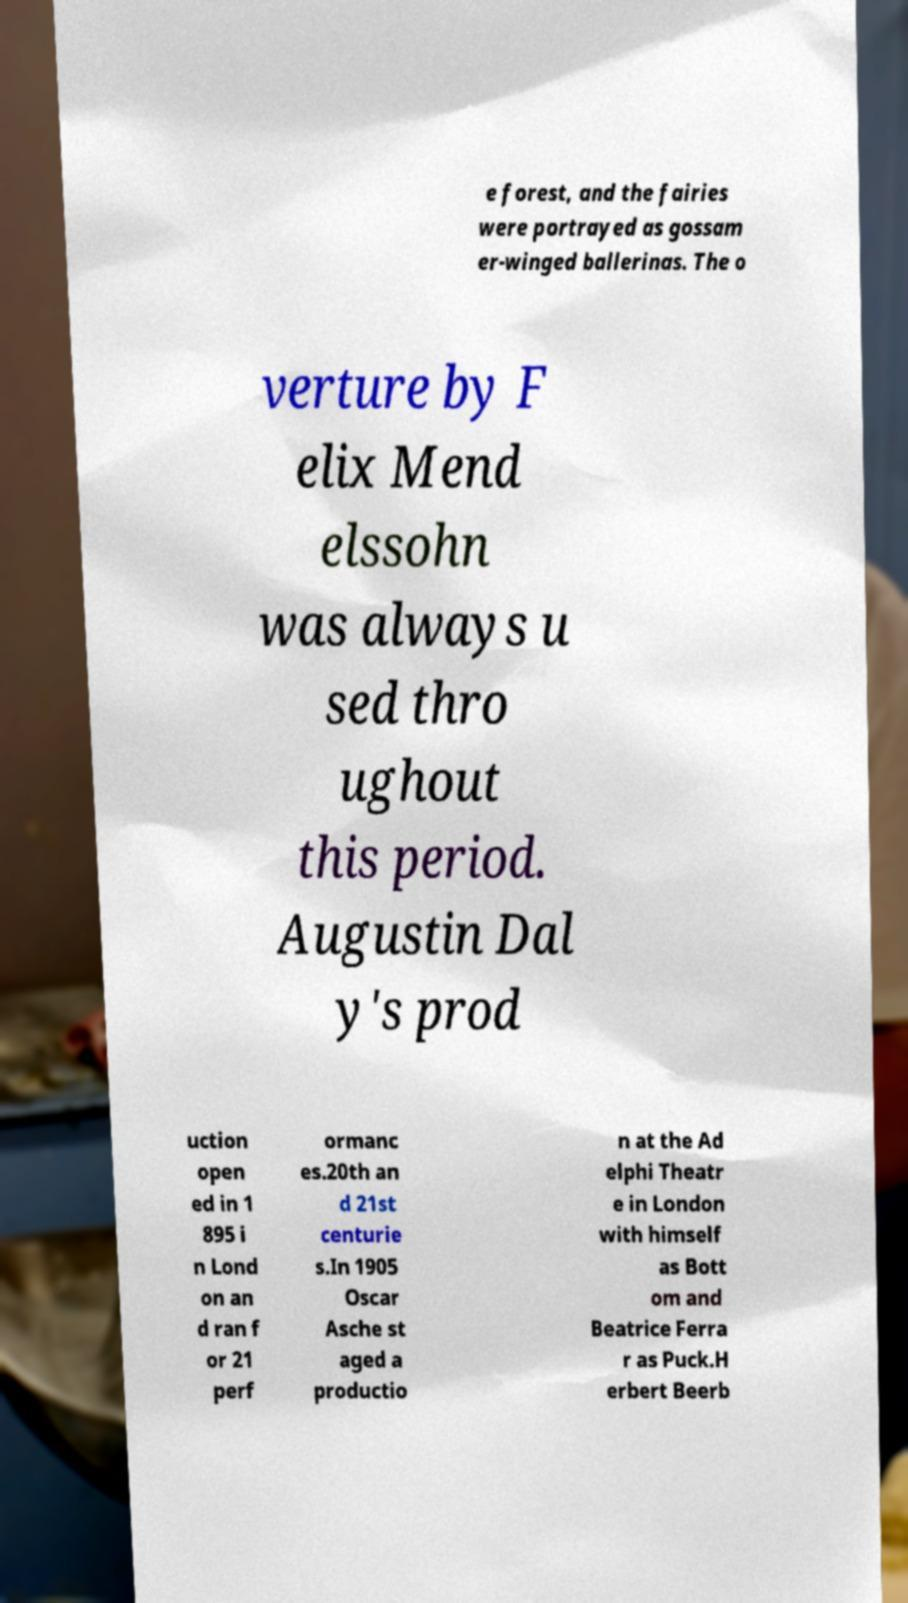Please read and relay the text visible in this image. What does it say? e forest, and the fairies were portrayed as gossam er-winged ballerinas. The o verture by F elix Mend elssohn was always u sed thro ughout this period. Augustin Dal y's prod uction open ed in 1 895 i n Lond on an d ran f or 21 perf ormanc es.20th an d 21st centurie s.In 1905 Oscar Asche st aged a productio n at the Ad elphi Theatr e in London with himself as Bott om and Beatrice Ferra r as Puck.H erbert Beerb 